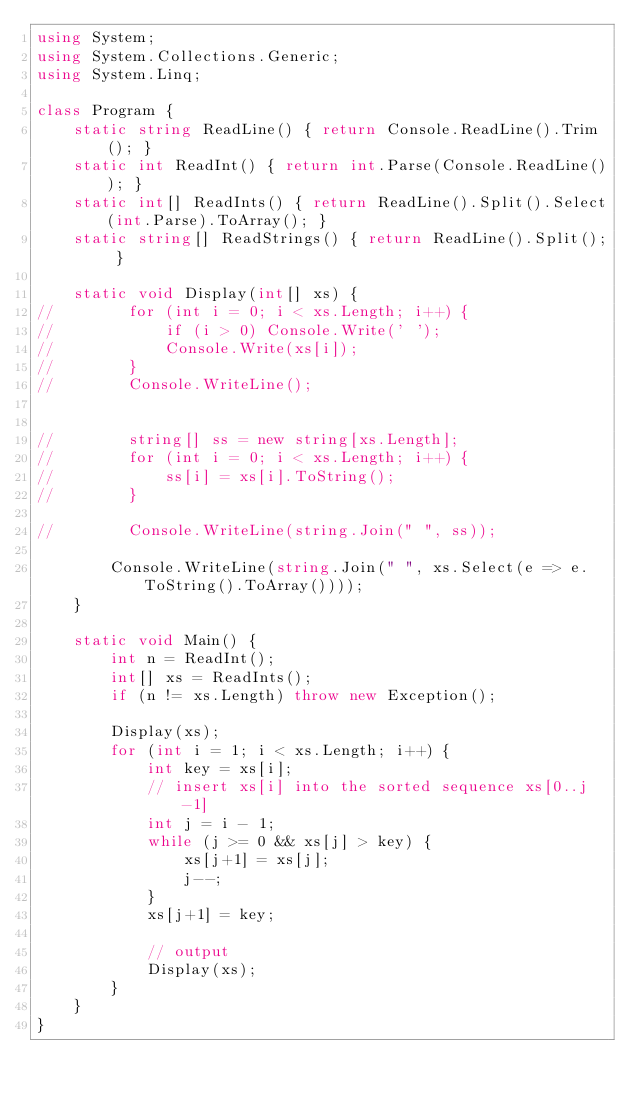Convert code to text. <code><loc_0><loc_0><loc_500><loc_500><_C#_>using System;
using System.Collections.Generic;
using System.Linq;

class Program {
    static string ReadLine() { return Console.ReadLine().Trim(); }
    static int ReadInt() { return int.Parse(Console.ReadLine()); }
    static int[] ReadInts() { return ReadLine().Split().Select(int.Parse).ToArray(); }
    static string[] ReadStrings() { return ReadLine().Split(); }

    static void Display(int[] xs) {
//        for (int i = 0; i < xs.Length; i++) {
//            if (i > 0) Console.Write(' ');
//            Console.Write(xs[i]);
//        }
//        Console.WriteLine();


//        string[] ss = new string[xs.Length];
//        for (int i = 0; i < xs.Length; i++) {
//            ss[i] = xs[i].ToString();
//        }

//        Console.WriteLine(string.Join(" ", ss));

        Console.WriteLine(string.Join(" ", xs.Select(e => e.ToString().ToArray())));
    }

    static void Main() {
        int n = ReadInt();
        int[] xs = ReadInts();
        if (n != xs.Length) throw new Exception();

        Display(xs);
        for (int i = 1; i < xs.Length; i++) {
            int key = xs[i];
            // insert xs[i] into the sorted sequence xs[0..j-1]
            int j = i - 1;
            while (j >= 0 && xs[j] > key) {
                xs[j+1] = xs[j];
                j--;
            }
            xs[j+1] = key;

            // output
            Display(xs);
        }
    }
}</code> 